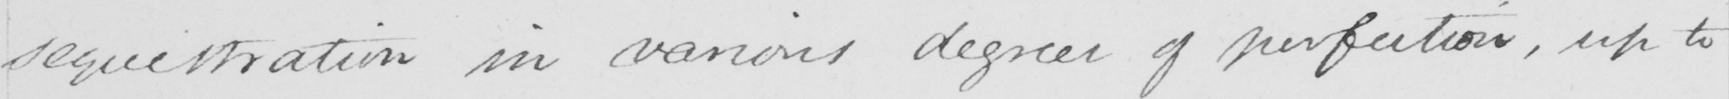What text is written in this handwritten line? sequestration in various degrees of perfection , up to 